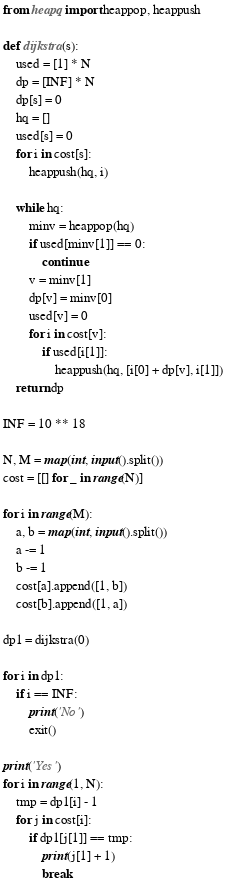<code> <loc_0><loc_0><loc_500><loc_500><_Python_>from heapq import heappop, heappush

def dijkstra(s):
    used = [1] * N
    dp = [INF] * N
    dp[s] = 0
    hq = []
    used[s] = 0
    for i in cost[s]:
        heappush(hq, i)

    while hq:
        minv = heappop(hq)
        if used[minv[1]] == 0:
            continue
        v = minv[1]
        dp[v] = minv[0]
        used[v] = 0
        for i in cost[v]:
            if used[i[1]]:
                heappush(hq, [i[0] + dp[v], i[1]])
    return dp

INF = 10 ** 18

N, M = map(int, input().split())
cost = [[] for _ in range(N)]

for i in range(M):
    a, b = map(int, input().split())
    a -= 1
    b -= 1
    cost[a].append([1, b])
    cost[b].append([1, a])

dp1 = dijkstra(0)

for i in dp1:
    if i == INF:
        print('No')
        exit()

print('Yes')
for i in range(1, N):
    tmp = dp1[i] - 1
    for j in cost[i]:
        if dp1[j[1]] == tmp:
            print(j[1] + 1)
            break</code> 